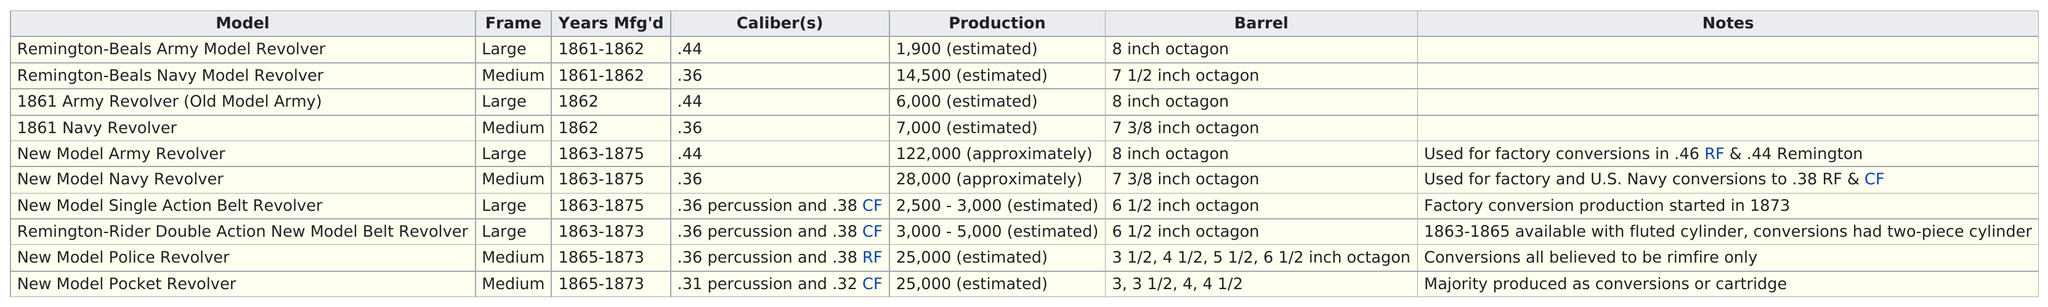Specify some key components in this picture. The Remington-Beals Army Model Revolver, 1861 Army Revolver (Old Model Army), New Model Army Revolver, and New Model Single Action Belt Revolver all have medium frames. On the other hand, the Remington-Rider Double Action New Model Belt Revolver does not have a medium frame. The New Model Pocket Revolver is the only model to have the lowest caliber, making it a unique and impressive firearm. The New Model Pocket Revolver was the last model to have been created. The New Model Army Revolver was the model that produced the most during the years of its manufacture. The Remington-Beals Army Model Revolver was the model with the least number of revolvers produced. 